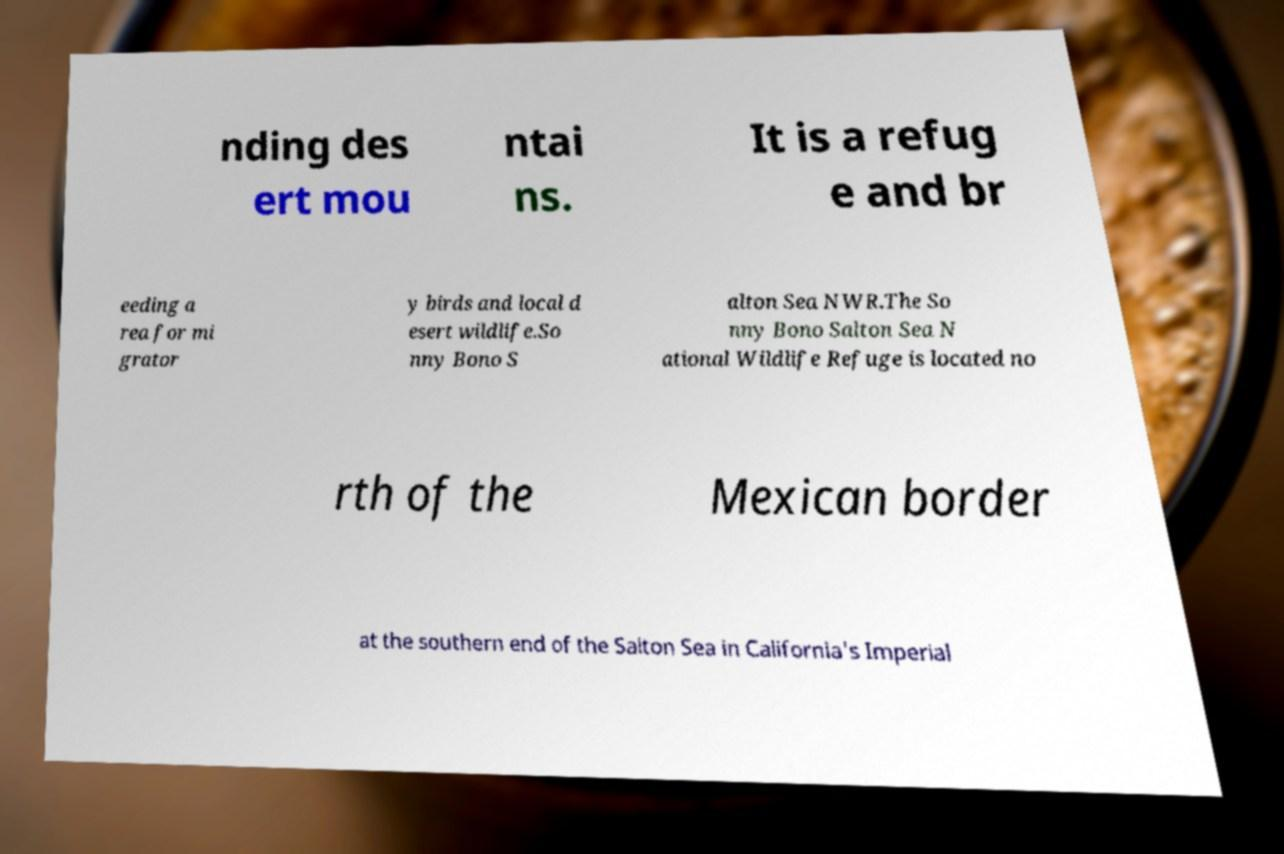I need the written content from this picture converted into text. Can you do that? nding des ert mou ntai ns. It is a refug e and br eeding a rea for mi grator y birds and local d esert wildlife.So nny Bono S alton Sea NWR.The So nny Bono Salton Sea N ational Wildlife Refuge is located no rth of the Mexican border at the southern end of the Salton Sea in California's Imperial 